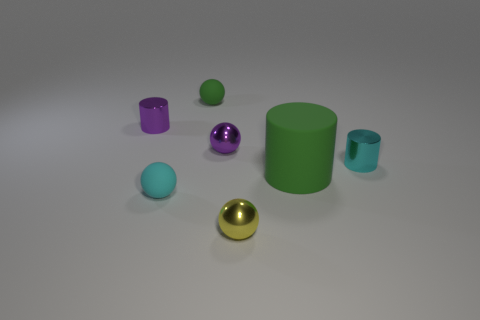Subtract all shiny cylinders. How many cylinders are left? 1 Add 2 green rubber spheres. How many objects exist? 9 Subtract all green cylinders. How many cylinders are left? 2 Subtract all cylinders. How many objects are left? 4 Add 7 large green cylinders. How many large green cylinders are left? 8 Add 3 small matte things. How many small matte things exist? 5 Subtract 0 gray cubes. How many objects are left? 7 Subtract 2 spheres. How many spheres are left? 2 Subtract all blue spheres. Subtract all red cylinders. How many spheres are left? 4 Subtract all rubber spheres. Subtract all cyan things. How many objects are left? 3 